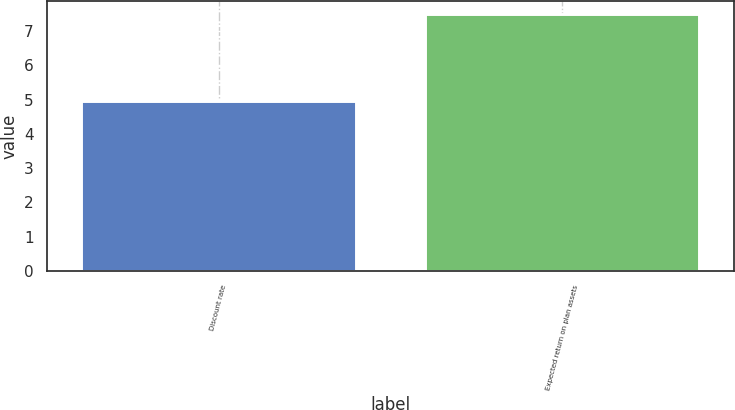<chart> <loc_0><loc_0><loc_500><loc_500><bar_chart><fcel>Discount rate<fcel>Expected return on plan assets<nl><fcel>4.95<fcel>7.5<nl></chart> 